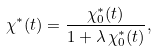Convert formula to latex. <formula><loc_0><loc_0><loc_500><loc_500>\chi ^ { * } ( t ) = \frac { \chi ^ { * } _ { 0 } ( t ) } { 1 + \lambda \, \chi ^ { * } _ { 0 } ( t ) } ,</formula> 